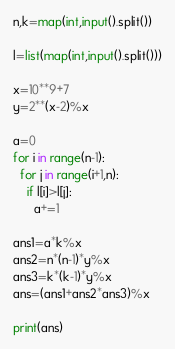Convert code to text. <code><loc_0><loc_0><loc_500><loc_500><_Python_>n,k=map(int,input().split())

l=list(map(int,input().split()))

x=10**9+7
y=2**(x-2)%x

a=0
for i in range(n-1):
  for j in range(i+1,n):
    if l[i]>l[j]:
      a+=1

ans1=a*k%x
ans2=n*(n-1)*y%x
ans3=k*(k-1)*y%x
ans=(ans1+ans2*ans3)%x

print(ans)</code> 